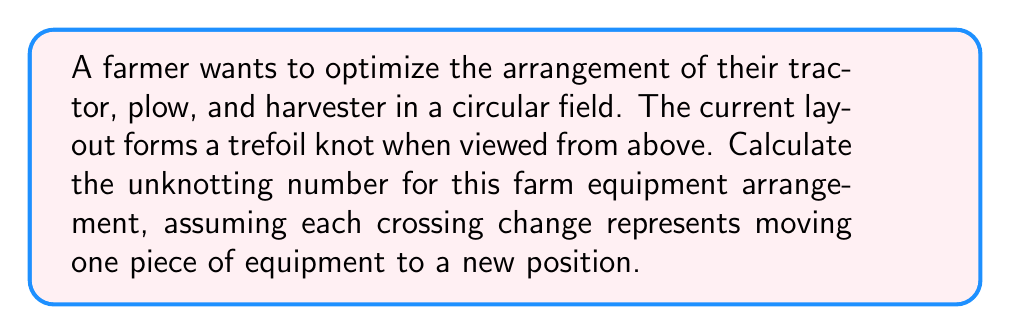Help me with this question. To solve this problem, we need to understand the concept of unknotting number and apply it to the trefoil knot formed by the farm equipment arrangement.

Step 1: Understand the unknotting number
The unknotting number of a knot is the minimum number of crossing changes required to transform the knot into an unknot (a simple closed curve with no crossings).

Step 2: Identify the knot
The problem states that the arrangement forms a trefoil knot. The trefoil knot is one of the simplest non-trivial knots.

Step 3: Recall the unknotting number of a trefoil knot
The unknotting number of a trefoil knot is 1. This means that changing any one of the three crossings in a trefoil knot diagram will result in an unknot.

Step 4: Interpret the result in terms of farm equipment
Each crossing change represents moving one piece of equipment to a new position. Therefore, the farmer needs to move only one piece of equipment (either the tractor, plow, or harvester) to a new position to simplify the arrangement into a circular layout without any crossings.

The unknotting number can be expressed mathematically as:

$$u(K_{trefoil}) = 1$$

Where $u(K)$ represents the unknotting number of a knot $K$.
Answer: 1 